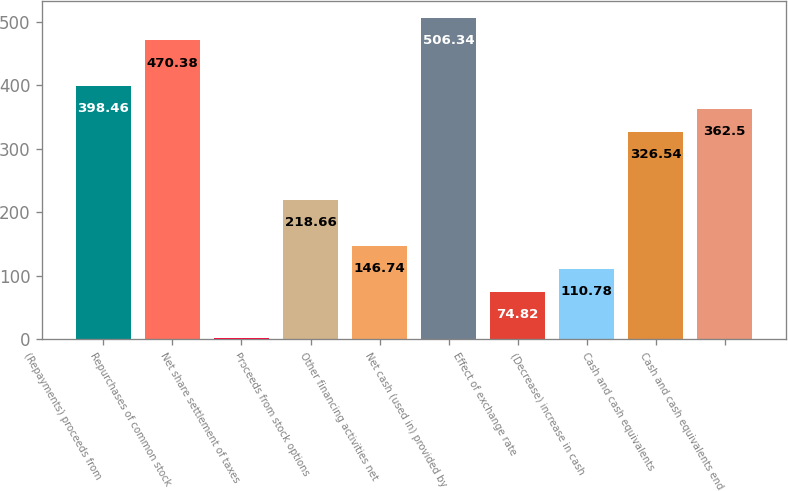<chart> <loc_0><loc_0><loc_500><loc_500><bar_chart><fcel>(Repayments) proceeds from<fcel>Repurchases of common stock<fcel>Net share settlement of taxes<fcel>Proceeds from stock options<fcel>Other financing activities net<fcel>Net cash (used in) provided by<fcel>Effect of exchange rate<fcel>(Decrease) increase in cash<fcel>Cash and cash equivalents<fcel>Cash and cash equivalents end<nl><fcel>398.46<fcel>470.38<fcel>2.9<fcel>218.66<fcel>146.74<fcel>506.34<fcel>74.82<fcel>110.78<fcel>326.54<fcel>362.5<nl></chart> 